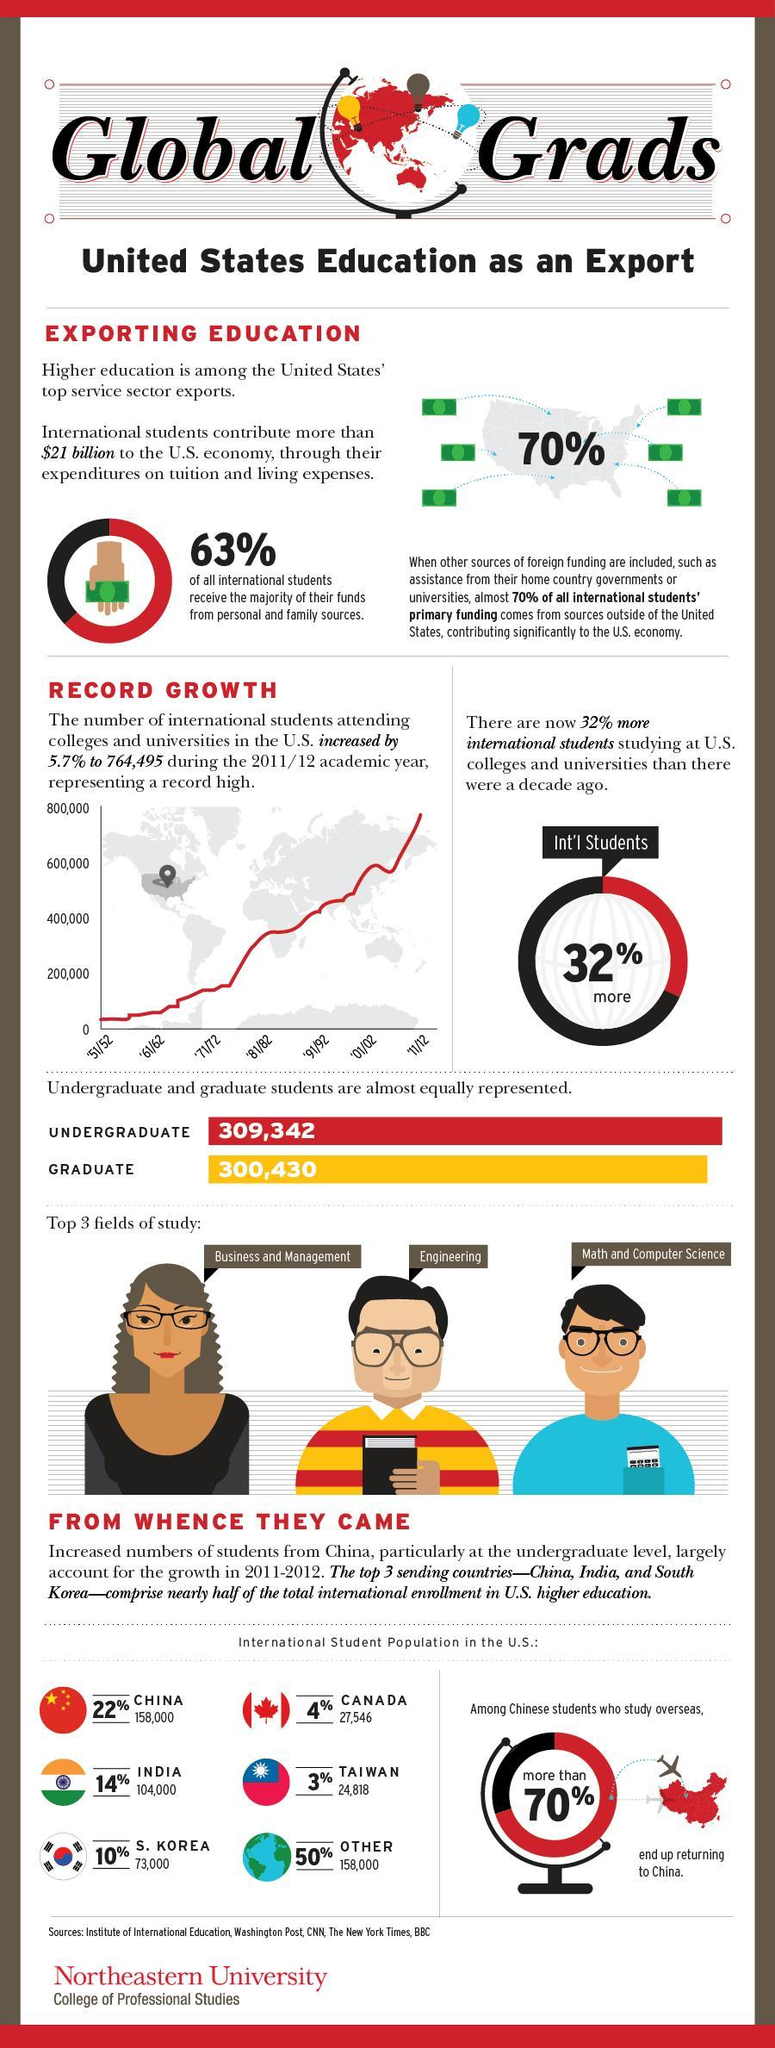What is the total percentage of international students from China and Other countries?
Answer the question with a short phrase. 72% What is the difference between graduates and undergraduates represented ? 8,912 Which are countries do not fall into the list top 3 countries that send students for higher studies to U.S.? Canada, Taiwan, Others 